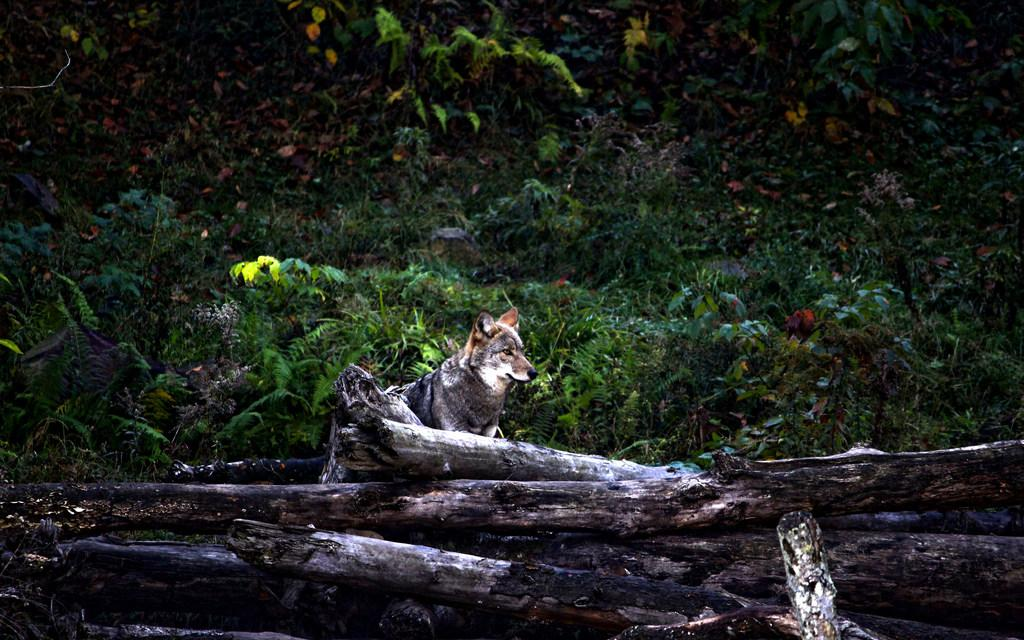What is the main object in the image? There is a log of wood in the image. Where is the dog located in the image? The dog is behind the log of wood. What can be seen in the background of the image? There are plants visible in the background of the image. What type of crime is being committed in the image? There is no crime being committed in the image; it features a log of wood and a dog. What color is the shirt worn by the sun in the image? There is no sun or shirt present in the image. 